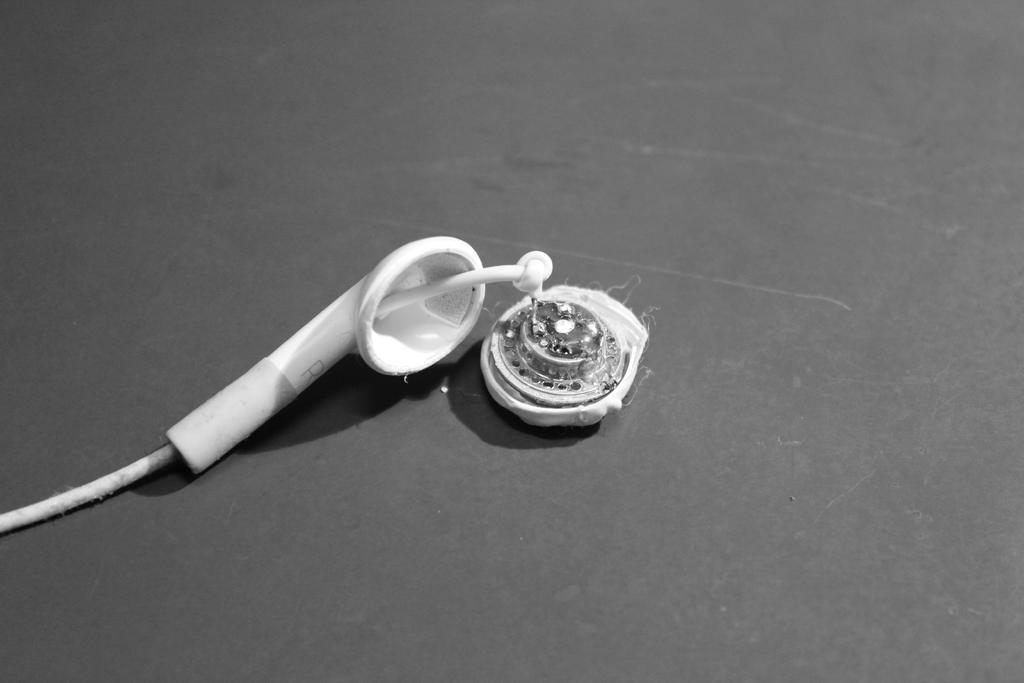What type of device is present in the image? There is an earphone in the image. Can you describe the color of the earphone? The earphone is white and grey in color. What is connected to the earphone in the image? There is a wire in the image, which is white in color. What is the color of the surface in the image? The surface in the image is black. How many giants are visible in the image? There are no giants present in the image. What type of wool is being used to create the earphone in the image? The earphone in the image is not made of wool; it is an electronic device. 